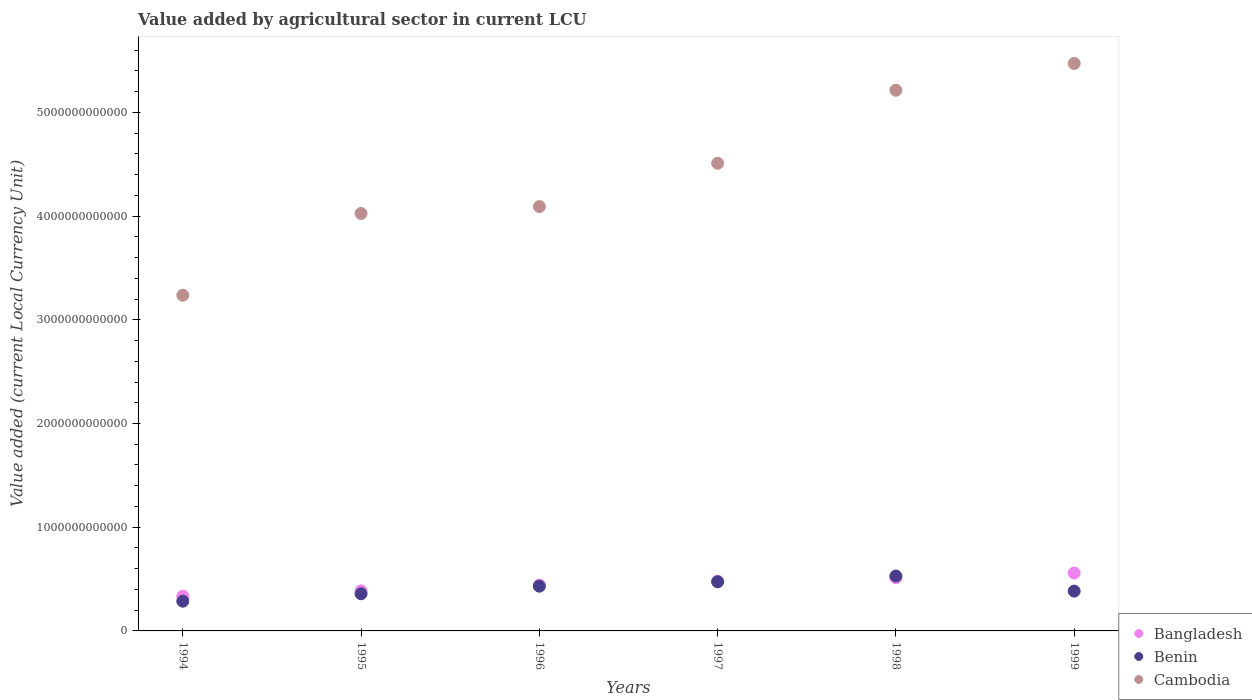What is the value added by agricultural sector in Bangladesh in 1994?
Offer a terse response. 3.35e+11. Across all years, what is the maximum value added by agricultural sector in Benin?
Keep it short and to the point. 5.30e+11. Across all years, what is the minimum value added by agricultural sector in Benin?
Offer a terse response. 2.87e+11. In which year was the value added by agricultural sector in Benin maximum?
Your answer should be compact. 1998. What is the total value added by agricultural sector in Cambodia in the graph?
Offer a very short reply. 2.65e+13. What is the difference between the value added by agricultural sector in Bangladesh in 1995 and that in 1998?
Your answer should be very brief. -1.26e+11. What is the difference between the value added by agricultural sector in Benin in 1998 and the value added by agricultural sector in Bangladesh in 1995?
Provide a short and direct response. 1.43e+11. What is the average value added by agricultural sector in Benin per year?
Your response must be concise. 4.11e+11. In the year 1996, what is the difference between the value added by agricultural sector in Cambodia and value added by agricultural sector in Benin?
Provide a succinct answer. 3.66e+12. In how many years, is the value added by agricultural sector in Benin greater than 2800000000000 LCU?
Give a very brief answer. 0. What is the ratio of the value added by agricultural sector in Bangladesh in 1997 to that in 1999?
Provide a succinct answer. 0.86. Is the value added by agricultural sector in Benin in 1995 less than that in 1997?
Provide a short and direct response. Yes. Is the difference between the value added by agricultural sector in Cambodia in 1997 and 1999 greater than the difference between the value added by agricultural sector in Benin in 1997 and 1999?
Make the answer very short. No. What is the difference between the highest and the second highest value added by agricultural sector in Benin?
Offer a terse response. 5.60e+1. What is the difference between the highest and the lowest value added by agricultural sector in Benin?
Your response must be concise. 2.43e+11. Is the sum of the value added by agricultural sector in Benin in 1997 and 1998 greater than the maximum value added by agricultural sector in Cambodia across all years?
Your answer should be very brief. No. How many years are there in the graph?
Your answer should be very brief. 6. What is the difference between two consecutive major ticks on the Y-axis?
Provide a succinct answer. 1.00e+12. Are the values on the major ticks of Y-axis written in scientific E-notation?
Ensure brevity in your answer.  No. Does the graph contain any zero values?
Keep it short and to the point. No. Does the graph contain grids?
Offer a terse response. No. Where does the legend appear in the graph?
Your answer should be compact. Bottom right. How many legend labels are there?
Your answer should be compact. 3. What is the title of the graph?
Offer a very short reply. Value added by agricultural sector in current LCU. What is the label or title of the X-axis?
Make the answer very short. Years. What is the label or title of the Y-axis?
Offer a very short reply. Value added (current Local Currency Unit). What is the Value added (current Local Currency Unit) of Bangladesh in 1994?
Your answer should be very brief. 3.35e+11. What is the Value added (current Local Currency Unit) of Benin in 1994?
Your answer should be compact. 2.87e+11. What is the Value added (current Local Currency Unit) in Cambodia in 1994?
Your answer should be compact. 3.24e+12. What is the Value added (current Local Currency Unit) of Bangladesh in 1995?
Your answer should be very brief. 3.86e+11. What is the Value added (current Local Currency Unit) of Benin in 1995?
Provide a succinct answer. 3.58e+11. What is the Value added (current Local Currency Unit) in Cambodia in 1995?
Your answer should be very brief. 4.02e+12. What is the Value added (current Local Currency Unit) of Bangladesh in 1996?
Give a very brief answer. 4.42e+11. What is the Value added (current Local Currency Unit) of Benin in 1996?
Your response must be concise. 4.31e+11. What is the Value added (current Local Currency Unit) in Cambodia in 1996?
Offer a very short reply. 4.09e+12. What is the Value added (current Local Currency Unit) in Bangladesh in 1997?
Your answer should be compact. 4.79e+11. What is the Value added (current Local Currency Unit) of Benin in 1997?
Keep it short and to the point. 4.74e+11. What is the Value added (current Local Currency Unit) in Cambodia in 1997?
Offer a terse response. 4.51e+12. What is the Value added (current Local Currency Unit) of Bangladesh in 1998?
Keep it short and to the point. 5.13e+11. What is the Value added (current Local Currency Unit) in Benin in 1998?
Your answer should be very brief. 5.30e+11. What is the Value added (current Local Currency Unit) of Cambodia in 1998?
Keep it short and to the point. 5.21e+12. What is the Value added (current Local Currency Unit) in Bangladesh in 1999?
Provide a succinct answer. 5.59e+11. What is the Value added (current Local Currency Unit) in Benin in 1999?
Provide a short and direct response. 3.84e+11. What is the Value added (current Local Currency Unit) in Cambodia in 1999?
Offer a very short reply. 5.47e+12. Across all years, what is the maximum Value added (current Local Currency Unit) in Bangladesh?
Offer a very short reply. 5.59e+11. Across all years, what is the maximum Value added (current Local Currency Unit) in Benin?
Give a very brief answer. 5.30e+11. Across all years, what is the maximum Value added (current Local Currency Unit) in Cambodia?
Provide a short and direct response. 5.47e+12. Across all years, what is the minimum Value added (current Local Currency Unit) in Bangladesh?
Offer a terse response. 3.35e+11. Across all years, what is the minimum Value added (current Local Currency Unit) of Benin?
Provide a short and direct response. 2.87e+11. Across all years, what is the minimum Value added (current Local Currency Unit) of Cambodia?
Provide a short and direct response. 3.24e+12. What is the total Value added (current Local Currency Unit) of Bangladesh in the graph?
Offer a terse response. 2.71e+12. What is the total Value added (current Local Currency Unit) in Benin in the graph?
Make the answer very short. 2.46e+12. What is the total Value added (current Local Currency Unit) of Cambodia in the graph?
Provide a short and direct response. 2.65e+13. What is the difference between the Value added (current Local Currency Unit) in Bangladesh in 1994 and that in 1995?
Offer a very short reply. -5.15e+1. What is the difference between the Value added (current Local Currency Unit) in Benin in 1994 and that in 1995?
Offer a terse response. -7.18e+1. What is the difference between the Value added (current Local Currency Unit) in Cambodia in 1994 and that in 1995?
Keep it short and to the point. -7.88e+11. What is the difference between the Value added (current Local Currency Unit) in Bangladesh in 1994 and that in 1996?
Give a very brief answer. -1.07e+11. What is the difference between the Value added (current Local Currency Unit) in Benin in 1994 and that in 1996?
Give a very brief answer. -1.45e+11. What is the difference between the Value added (current Local Currency Unit) of Cambodia in 1994 and that in 1996?
Give a very brief answer. -8.55e+11. What is the difference between the Value added (current Local Currency Unit) of Bangladesh in 1994 and that in 1997?
Your answer should be compact. -1.44e+11. What is the difference between the Value added (current Local Currency Unit) in Benin in 1994 and that in 1997?
Your response must be concise. -1.87e+11. What is the difference between the Value added (current Local Currency Unit) of Cambodia in 1994 and that in 1997?
Your answer should be very brief. -1.27e+12. What is the difference between the Value added (current Local Currency Unit) in Bangladesh in 1994 and that in 1998?
Give a very brief answer. -1.78e+11. What is the difference between the Value added (current Local Currency Unit) of Benin in 1994 and that in 1998?
Your response must be concise. -2.43e+11. What is the difference between the Value added (current Local Currency Unit) of Cambodia in 1994 and that in 1998?
Your answer should be very brief. -1.98e+12. What is the difference between the Value added (current Local Currency Unit) in Bangladesh in 1994 and that in 1999?
Provide a succinct answer. -2.24e+11. What is the difference between the Value added (current Local Currency Unit) in Benin in 1994 and that in 1999?
Your answer should be compact. -9.74e+1. What is the difference between the Value added (current Local Currency Unit) in Cambodia in 1994 and that in 1999?
Offer a terse response. -2.23e+12. What is the difference between the Value added (current Local Currency Unit) in Bangladesh in 1995 and that in 1996?
Your response must be concise. -5.55e+1. What is the difference between the Value added (current Local Currency Unit) of Benin in 1995 and that in 1996?
Give a very brief answer. -7.29e+1. What is the difference between the Value added (current Local Currency Unit) of Cambodia in 1995 and that in 1996?
Make the answer very short. -6.65e+1. What is the difference between the Value added (current Local Currency Unit) of Bangladesh in 1995 and that in 1997?
Keep it short and to the point. -9.25e+1. What is the difference between the Value added (current Local Currency Unit) of Benin in 1995 and that in 1997?
Offer a very short reply. -1.15e+11. What is the difference between the Value added (current Local Currency Unit) in Cambodia in 1995 and that in 1997?
Make the answer very short. -4.84e+11. What is the difference between the Value added (current Local Currency Unit) in Bangladesh in 1995 and that in 1998?
Provide a succinct answer. -1.26e+11. What is the difference between the Value added (current Local Currency Unit) of Benin in 1995 and that in 1998?
Provide a succinct answer. -1.71e+11. What is the difference between the Value added (current Local Currency Unit) of Cambodia in 1995 and that in 1998?
Your answer should be very brief. -1.19e+12. What is the difference between the Value added (current Local Currency Unit) of Bangladesh in 1995 and that in 1999?
Your response must be concise. -1.72e+11. What is the difference between the Value added (current Local Currency Unit) in Benin in 1995 and that in 1999?
Keep it short and to the point. -2.55e+1. What is the difference between the Value added (current Local Currency Unit) in Cambodia in 1995 and that in 1999?
Your answer should be compact. -1.45e+12. What is the difference between the Value added (current Local Currency Unit) of Bangladesh in 1996 and that in 1997?
Keep it short and to the point. -3.70e+1. What is the difference between the Value added (current Local Currency Unit) in Benin in 1996 and that in 1997?
Provide a short and direct response. -4.25e+1. What is the difference between the Value added (current Local Currency Unit) in Cambodia in 1996 and that in 1997?
Offer a very short reply. -4.18e+11. What is the difference between the Value added (current Local Currency Unit) in Bangladesh in 1996 and that in 1998?
Your answer should be very brief. -7.07e+1. What is the difference between the Value added (current Local Currency Unit) in Benin in 1996 and that in 1998?
Your answer should be very brief. -9.85e+1. What is the difference between the Value added (current Local Currency Unit) of Cambodia in 1996 and that in 1998?
Give a very brief answer. -1.12e+12. What is the difference between the Value added (current Local Currency Unit) of Bangladesh in 1996 and that in 1999?
Keep it short and to the point. -1.17e+11. What is the difference between the Value added (current Local Currency Unit) of Benin in 1996 and that in 1999?
Make the answer very short. 4.74e+1. What is the difference between the Value added (current Local Currency Unit) of Cambodia in 1996 and that in 1999?
Your response must be concise. -1.38e+12. What is the difference between the Value added (current Local Currency Unit) in Bangladesh in 1997 and that in 1998?
Offer a terse response. -3.37e+1. What is the difference between the Value added (current Local Currency Unit) in Benin in 1997 and that in 1998?
Provide a short and direct response. -5.60e+1. What is the difference between the Value added (current Local Currency Unit) in Cambodia in 1997 and that in 1998?
Provide a short and direct response. -7.04e+11. What is the difference between the Value added (current Local Currency Unit) of Bangladesh in 1997 and that in 1999?
Provide a succinct answer. -7.97e+1. What is the difference between the Value added (current Local Currency Unit) of Benin in 1997 and that in 1999?
Give a very brief answer. 8.98e+1. What is the difference between the Value added (current Local Currency Unit) of Cambodia in 1997 and that in 1999?
Your answer should be compact. -9.62e+11. What is the difference between the Value added (current Local Currency Unit) in Bangladesh in 1998 and that in 1999?
Offer a very short reply. -4.60e+1. What is the difference between the Value added (current Local Currency Unit) of Benin in 1998 and that in 1999?
Give a very brief answer. 1.46e+11. What is the difference between the Value added (current Local Currency Unit) in Cambodia in 1998 and that in 1999?
Ensure brevity in your answer.  -2.58e+11. What is the difference between the Value added (current Local Currency Unit) in Bangladesh in 1994 and the Value added (current Local Currency Unit) in Benin in 1995?
Keep it short and to the point. -2.35e+1. What is the difference between the Value added (current Local Currency Unit) in Bangladesh in 1994 and the Value added (current Local Currency Unit) in Cambodia in 1995?
Keep it short and to the point. -3.69e+12. What is the difference between the Value added (current Local Currency Unit) in Benin in 1994 and the Value added (current Local Currency Unit) in Cambodia in 1995?
Offer a very short reply. -3.74e+12. What is the difference between the Value added (current Local Currency Unit) in Bangladesh in 1994 and the Value added (current Local Currency Unit) in Benin in 1996?
Your answer should be compact. -9.64e+1. What is the difference between the Value added (current Local Currency Unit) in Bangladesh in 1994 and the Value added (current Local Currency Unit) in Cambodia in 1996?
Provide a succinct answer. -3.76e+12. What is the difference between the Value added (current Local Currency Unit) in Benin in 1994 and the Value added (current Local Currency Unit) in Cambodia in 1996?
Give a very brief answer. -3.80e+12. What is the difference between the Value added (current Local Currency Unit) of Bangladesh in 1994 and the Value added (current Local Currency Unit) of Benin in 1997?
Your answer should be very brief. -1.39e+11. What is the difference between the Value added (current Local Currency Unit) of Bangladesh in 1994 and the Value added (current Local Currency Unit) of Cambodia in 1997?
Your answer should be very brief. -4.17e+12. What is the difference between the Value added (current Local Currency Unit) of Benin in 1994 and the Value added (current Local Currency Unit) of Cambodia in 1997?
Offer a very short reply. -4.22e+12. What is the difference between the Value added (current Local Currency Unit) of Bangladesh in 1994 and the Value added (current Local Currency Unit) of Benin in 1998?
Your response must be concise. -1.95e+11. What is the difference between the Value added (current Local Currency Unit) of Bangladesh in 1994 and the Value added (current Local Currency Unit) of Cambodia in 1998?
Your answer should be very brief. -4.88e+12. What is the difference between the Value added (current Local Currency Unit) of Benin in 1994 and the Value added (current Local Currency Unit) of Cambodia in 1998?
Make the answer very short. -4.93e+12. What is the difference between the Value added (current Local Currency Unit) of Bangladesh in 1994 and the Value added (current Local Currency Unit) of Benin in 1999?
Give a very brief answer. -4.91e+1. What is the difference between the Value added (current Local Currency Unit) of Bangladesh in 1994 and the Value added (current Local Currency Unit) of Cambodia in 1999?
Offer a very short reply. -5.14e+12. What is the difference between the Value added (current Local Currency Unit) of Benin in 1994 and the Value added (current Local Currency Unit) of Cambodia in 1999?
Provide a succinct answer. -5.18e+12. What is the difference between the Value added (current Local Currency Unit) in Bangladesh in 1995 and the Value added (current Local Currency Unit) in Benin in 1996?
Your answer should be very brief. -4.49e+1. What is the difference between the Value added (current Local Currency Unit) in Bangladesh in 1995 and the Value added (current Local Currency Unit) in Cambodia in 1996?
Make the answer very short. -3.71e+12. What is the difference between the Value added (current Local Currency Unit) in Benin in 1995 and the Value added (current Local Currency Unit) in Cambodia in 1996?
Ensure brevity in your answer.  -3.73e+12. What is the difference between the Value added (current Local Currency Unit) of Bangladesh in 1995 and the Value added (current Local Currency Unit) of Benin in 1997?
Keep it short and to the point. -8.74e+1. What is the difference between the Value added (current Local Currency Unit) in Bangladesh in 1995 and the Value added (current Local Currency Unit) in Cambodia in 1997?
Your answer should be compact. -4.12e+12. What is the difference between the Value added (current Local Currency Unit) in Benin in 1995 and the Value added (current Local Currency Unit) in Cambodia in 1997?
Offer a terse response. -4.15e+12. What is the difference between the Value added (current Local Currency Unit) of Bangladesh in 1995 and the Value added (current Local Currency Unit) of Benin in 1998?
Keep it short and to the point. -1.43e+11. What is the difference between the Value added (current Local Currency Unit) in Bangladesh in 1995 and the Value added (current Local Currency Unit) in Cambodia in 1998?
Make the answer very short. -4.83e+12. What is the difference between the Value added (current Local Currency Unit) in Benin in 1995 and the Value added (current Local Currency Unit) in Cambodia in 1998?
Provide a succinct answer. -4.85e+12. What is the difference between the Value added (current Local Currency Unit) of Bangladesh in 1995 and the Value added (current Local Currency Unit) of Benin in 1999?
Provide a succinct answer. 2.47e+09. What is the difference between the Value added (current Local Currency Unit) of Bangladesh in 1995 and the Value added (current Local Currency Unit) of Cambodia in 1999?
Ensure brevity in your answer.  -5.08e+12. What is the difference between the Value added (current Local Currency Unit) of Benin in 1995 and the Value added (current Local Currency Unit) of Cambodia in 1999?
Provide a succinct answer. -5.11e+12. What is the difference between the Value added (current Local Currency Unit) in Bangladesh in 1996 and the Value added (current Local Currency Unit) in Benin in 1997?
Your answer should be very brief. -3.18e+1. What is the difference between the Value added (current Local Currency Unit) in Bangladesh in 1996 and the Value added (current Local Currency Unit) in Cambodia in 1997?
Your answer should be compact. -4.07e+12. What is the difference between the Value added (current Local Currency Unit) in Benin in 1996 and the Value added (current Local Currency Unit) in Cambodia in 1997?
Your response must be concise. -4.08e+12. What is the difference between the Value added (current Local Currency Unit) of Bangladesh in 1996 and the Value added (current Local Currency Unit) of Benin in 1998?
Make the answer very short. -8.79e+1. What is the difference between the Value added (current Local Currency Unit) of Bangladesh in 1996 and the Value added (current Local Currency Unit) of Cambodia in 1998?
Give a very brief answer. -4.77e+12. What is the difference between the Value added (current Local Currency Unit) in Benin in 1996 and the Value added (current Local Currency Unit) in Cambodia in 1998?
Ensure brevity in your answer.  -4.78e+12. What is the difference between the Value added (current Local Currency Unit) in Bangladesh in 1996 and the Value added (current Local Currency Unit) in Benin in 1999?
Give a very brief answer. 5.80e+1. What is the difference between the Value added (current Local Currency Unit) of Bangladesh in 1996 and the Value added (current Local Currency Unit) of Cambodia in 1999?
Provide a succinct answer. -5.03e+12. What is the difference between the Value added (current Local Currency Unit) in Benin in 1996 and the Value added (current Local Currency Unit) in Cambodia in 1999?
Give a very brief answer. -5.04e+12. What is the difference between the Value added (current Local Currency Unit) of Bangladesh in 1997 and the Value added (current Local Currency Unit) of Benin in 1998?
Your answer should be very brief. -5.09e+1. What is the difference between the Value added (current Local Currency Unit) of Bangladesh in 1997 and the Value added (current Local Currency Unit) of Cambodia in 1998?
Provide a succinct answer. -4.73e+12. What is the difference between the Value added (current Local Currency Unit) of Benin in 1997 and the Value added (current Local Currency Unit) of Cambodia in 1998?
Offer a terse response. -4.74e+12. What is the difference between the Value added (current Local Currency Unit) of Bangladesh in 1997 and the Value added (current Local Currency Unit) of Benin in 1999?
Offer a very short reply. 9.50e+1. What is the difference between the Value added (current Local Currency Unit) of Bangladesh in 1997 and the Value added (current Local Currency Unit) of Cambodia in 1999?
Offer a very short reply. -4.99e+12. What is the difference between the Value added (current Local Currency Unit) of Benin in 1997 and the Value added (current Local Currency Unit) of Cambodia in 1999?
Provide a short and direct response. -5.00e+12. What is the difference between the Value added (current Local Currency Unit) of Bangladesh in 1998 and the Value added (current Local Currency Unit) of Benin in 1999?
Your response must be concise. 1.29e+11. What is the difference between the Value added (current Local Currency Unit) of Bangladesh in 1998 and the Value added (current Local Currency Unit) of Cambodia in 1999?
Keep it short and to the point. -4.96e+12. What is the difference between the Value added (current Local Currency Unit) of Benin in 1998 and the Value added (current Local Currency Unit) of Cambodia in 1999?
Provide a short and direct response. -4.94e+12. What is the average Value added (current Local Currency Unit) in Bangladesh per year?
Give a very brief answer. 4.52e+11. What is the average Value added (current Local Currency Unit) in Benin per year?
Your response must be concise. 4.11e+11. What is the average Value added (current Local Currency Unit) in Cambodia per year?
Make the answer very short. 4.42e+12. In the year 1994, what is the difference between the Value added (current Local Currency Unit) in Bangladesh and Value added (current Local Currency Unit) in Benin?
Offer a very short reply. 4.83e+1. In the year 1994, what is the difference between the Value added (current Local Currency Unit) in Bangladesh and Value added (current Local Currency Unit) in Cambodia?
Offer a very short reply. -2.90e+12. In the year 1994, what is the difference between the Value added (current Local Currency Unit) in Benin and Value added (current Local Currency Unit) in Cambodia?
Your answer should be compact. -2.95e+12. In the year 1995, what is the difference between the Value added (current Local Currency Unit) of Bangladesh and Value added (current Local Currency Unit) of Benin?
Your answer should be very brief. 2.80e+1. In the year 1995, what is the difference between the Value added (current Local Currency Unit) in Bangladesh and Value added (current Local Currency Unit) in Cambodia?
Provide a short and direct response. -3.64e+12. In the year 1995, what is the difference between the Value added (current Local Currency Unit) of Benin and Value added (current Local Currency Unit) of Cambodia?
Your answer should be very brief. -3.67e+12. In the year 1996, what is the difference between the Value added (current Local Currency Unit) of Bangladesh and Value added (current Local Currency Unit) of Benin?
Your answer should be compact. 1.06e+1. In the year 1996, what is the difference between the Value added (current Local Currency Unit) in Bangladesh and Value added (current Local Currency Unit) in Cambodia?
Provide a short and direct response. -3.65e+12. In the year 1996, what is the difference between the Value added (current Local Currency Unit) of Benin and Value added (current Local Currency Unit) of Cambodia?
Provide a short and direct response. -3.66e+12. In the year 1997, what is the difference between the Value added (current Local Currency Unit) of Bangladesh and Value added (current Local Currency Unit) of Benin?
Your response must be concise. 5.15e+09. In the year 1997, what is the difference between the Value added (current Local Currency Unit) of Bangladesh and Value added (current Local Currency Unit) of Cambodia?
Offer a very short reply. -4.03e+12. In the year 1997, what is the difference between the Value added (current Local Currency Unit) in Benin and Value added (current Local Currency Unit) in Cambodia?
Your response must be concise. -4.04e+12. In the year 1998, what is the difference between the Value added (current Local Currency Unit) in Bangladesh and Value added (current Local Currency Unit) in Benin?
Give a very brief answer. -1.72e+1. In the year 1998, what is the difference between the Value added (current Local Currency Unit) of Bangladesh and Value added (current Local Currency Unit) of Cambodia?
Make the answer very short. -4.70e+12. In the year 1998, what is the difference between the Value added (current Local Currency Unit) of Benin and Value added (current Local Currency Unit) of Cambodia?
Give a very brief answer. -4.68e+12. In the year 1999, what is the difference between the Value added (current Local Currency Unit) in Bangladesh and Value added (current Local Currency Unit) in Benin?
Offer a very short reply. 1.75e+11. In the year 1999, what is the difference between the Value added (current Local Currency Unit) of Bangladesh and Value added (current Local Currency Unit) of Cambodia?
Give a very brief answer. -4.91e+12. In the year 1999, what is the difference between the Value added (current Local Currency Unit) in Benin and Value added (current Local Currency Unit) in Cambodia?
Your response must be concise. -5.09e+12. What is the ratio of the Value added (current Local Currency Unit) in Bangladesh in 1994 to that in 1995?
Your answer should be very brief. 0.87. What is the ratio of the Value added (current Local Currency Unit) in Benin in 1994 to that in 1995?
Your response must be concise. 0.8. What is the ratio of the Value added (current Local Currency Unit) of Cambodia in 1994 to that in 1995?
Provide a short and direct response. 0.8. What is the ratio of the Value added (current Local Currency Unit) in Bangladesh in 1994 to that in 1996?
Make the answer very short. 0.76. What is the ratio of the Value added (current Local Currency Unit) of Benin in 1994 to that in 1996?
Your answer should be very brief. 0.66. What is the ratio of the Value added (current Local Currency Unit) of Cambodia in 1994 to that in 1996?
Provide a short and direct response. 0.79. What is the ratio of the Value added (current Local Currency Unit) of Bangladesh in 1994 to that in 1997?
Give a very brief answer. 0.7. What is the ratio of the Value added (current Local Currency Unit) of Benin in 1994 to that in 1997?
Keep it short and to the point. 0.6. What is the ratio of the Value added (current Local Currency Unit) of Cambodia in 1994 to that in 1997?
Offer a terse response. 0.72. What is the ratio of the Value added (current Local Currency Unit) in Bangladesh in 1994 to that in 1998?
Ensure brevity in your answer.  0.65. What is the ratio of the Value added (current Local Currency Unit) in Benin in 1994 to that in 1998?
Offer a very short reply. 0.54. What is the ratio of the Value added (current Local Currency Unit) in Cambodia in 1994 to that in 1998?
Offer a very short reply. 0.62. What is the ratio of the Value added (current Local Currency Unit) of Bangladesh in 1994 to that in 1999?
Your answer should be very brief. 0.6. What is the ratio of the Value added (current Local Currency Unit) in Benin in 1994 to that in 1999?
Your response must be concise. 0.75. What is the ratio of the Value added (current Local Currency Unit) of Cambodia in 1994 to that in 1999?
Provide a short and direct response. 0.59. What is the ratio of the Value added (current Local Currency Unit) of Bangladesh in 1995 to that in 1996?
Keep it short and to the point. 0.87. What is the ratio of the Value added (current Local Currency Unit) of Benin in 1995 to that in 1996?
Give a very brief answer. 0.83. What is the ratio of the Value added (current Local Currency Unit) in Cambodia in 1995 to that in 1996?
Provide a succinct answer. 0.98. What is the ratio of the Value added (current Local Currency Unit) in Bangladesh in 1995 to that in 1997?
Provide a succinct answer. 0.81. What is the ratio of the Value added (current Local Currency Unit) in Benin in 1995 to that in 1997?
Offer a very short reply. 0.76. What is the ratio of the Value added (current Local Currency Unit) in Cambodia in 1995 to that in 1997?
Keep it short and to the point. 0.89. What is the ratio of the Value added (current Local Currency Unit) of Bangladesh in 1995 to that in 1998?
Ensure brevity in your answer.  0.75. What is the ratio of the Value added (current Local Currency Unit) in Benin in 1995 to that in 1998?
Your response must be concise. 0.68. What is the ratio of the Value added (current Local Currency Unit) in Cambodia in 1995 to that in 1998?
Your response must be concise. 0.77. What is the ratio of the Value added (current Local Currency Unit) of Bangladesh in 1995 to that in 1999?
Your answer should be very brief. 0.69. What is the ratio of the Value added (current Local Currency Unit) of Benin in 1995 to that in 1999?
Give a very brief answer. 0.93. What is the ratio of the Value added (current Local Currency Unit) of Cambodia in 1995 to that in 1999?
Give a very brief answer. 0.74. What is the ratio of the Value added (current Local Currency Unit) in Bangladesh in 1996 to that in 1997?
Your answer should be very brief. 0.92. What is the ratio of the Value added (current Local Currency Unit) in Benin in 1996 to that in 1997?
Offer a very short reply. 0.91. What is the ratio of the Value added (current Local Currency Unit) of Cambodia in 1996 to that in 1997?
Provide a succinct answer. 0.91. What is the ratio of the Value added (current Local Currency Unit) in Bangladesh in 1996 to that in 1998?
Your answer should be compact. 0.86. What is the ratio of the Value added (current Local Currency Unit) of Benin in 1996 to that in 1998?
Offer a terse response. 0.81. What is the ratio of the Value added (current Local Currency Unit) of Cambodia in 1996 to that in 1998?
Make the answer very short. 0.78. What is the ratio of the Value added (current Local Currency Unit) of Bangladesh in 1996 to that in 1999?
Your response must be concise. 0.79. What is the ratio of the Value added (current Local Currency Unit) of Benin in 1996 to that in 1999?
Your answer should be compact. 1.12. What is the ratio of the Value added (current Local Currency Unit) of Cambodia in 1996 to that in 1999?
Make the answer very short. 0.75. What is the ratio of the Value added (current Local Currency Unit) in Bangladesh in 1997 to that in 1998?
Your response must be concise. 0.93. What is the ratio of the Value added (current Local Currency Unit) in Benin in 1997 to that in 1998?
Offer a terse response. 0.89. What is the ratio of the Value added (current Local Currency Unit) of Cambodia in 1997 to that in 1998?
Your answer should be compact. 0.86. What is the ratio of the Value added (current Local Currency Unit) in Bangladesh in 1997 to that in 1999?
Your response must be concise. 0.86. What is the ratio of the Value added (current Local Currency Unit) of Benin in 1997 to that in 1999?
Make the answer very short. 1.23. What is the ratio of the Value added (current Local Currency Unit) in Cambodia in 1997 to that in 1999?
Ensure brevity in your answer.  0.82. What is the ratio of the Value added (current Local Currency Unit) in Bangladesh in 1998 to that in 1999?
Make the answer very short. 0.92. What is the ratio of the Value added (current Local Currency Unit) in Benin in 1998 to that in 1999?
Your answer should be compact. 1.38. What is the ratio of the Value added (current Local Currency Unit) of Cambodia in 1998 to that in 1999?
Provide a short and direct response. 0.95. What is the difference between the highest and the second highest Value added (current Local Currency Unit) in Bangladesh?
Make the answer very short. 4.60e+1. What is the difference between the highest and the second highest Value added (current Local Currency Unit) in Benin?
Provide a succinct answer. 5.60e+1. What is the difference between the highest and the second highest Value added (current Local Currency Unit) in Cambodia?
Your response must be concise. 2.58e+11. What is the difference between the highest and the lowest Value added (current Local Currency Unit) of Bangladesh?
Your answer should be very brief. 2.24e+11. What is the difference between the highest and the lowest Value added (current Local Currency Unit) of Benin?
Your answer should be very brief. 2.43e+11. What is the difference between the highest and the lowest Value added (current Local Currency Unit) of Cambodia?
Your response must be concise. 2.23e+12. 